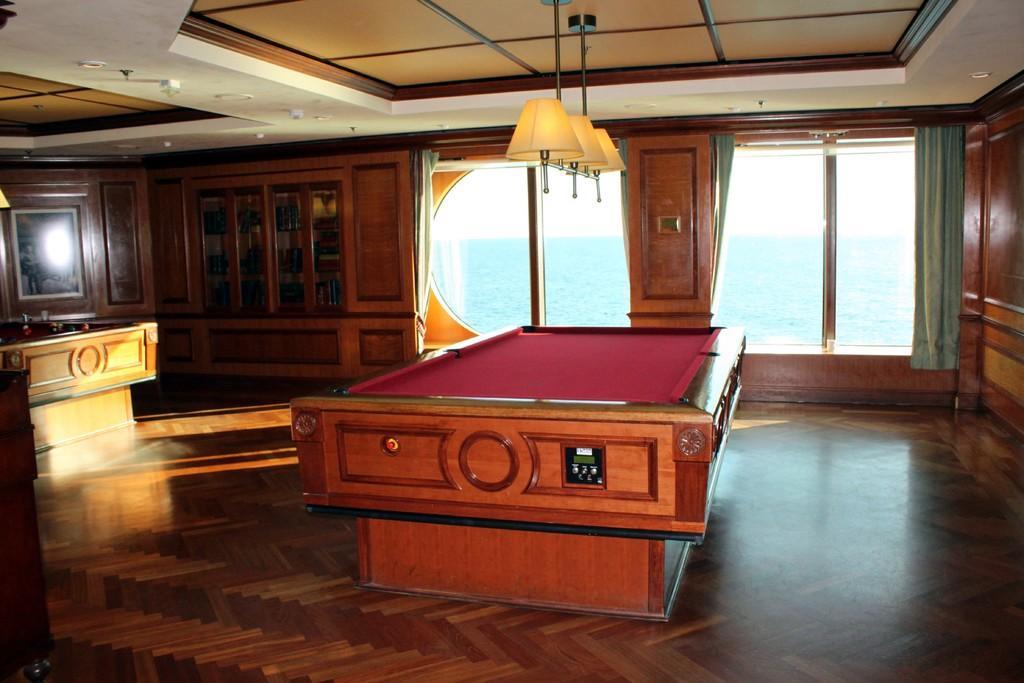Describe this image in one or two sentences. In this image in the center there is one table and on the right side there is one wooden wall and on the top there is a ceiling and some lights are there and in the middle there is a glass window and curtains are there and on the top of the right there is a cupboard. 